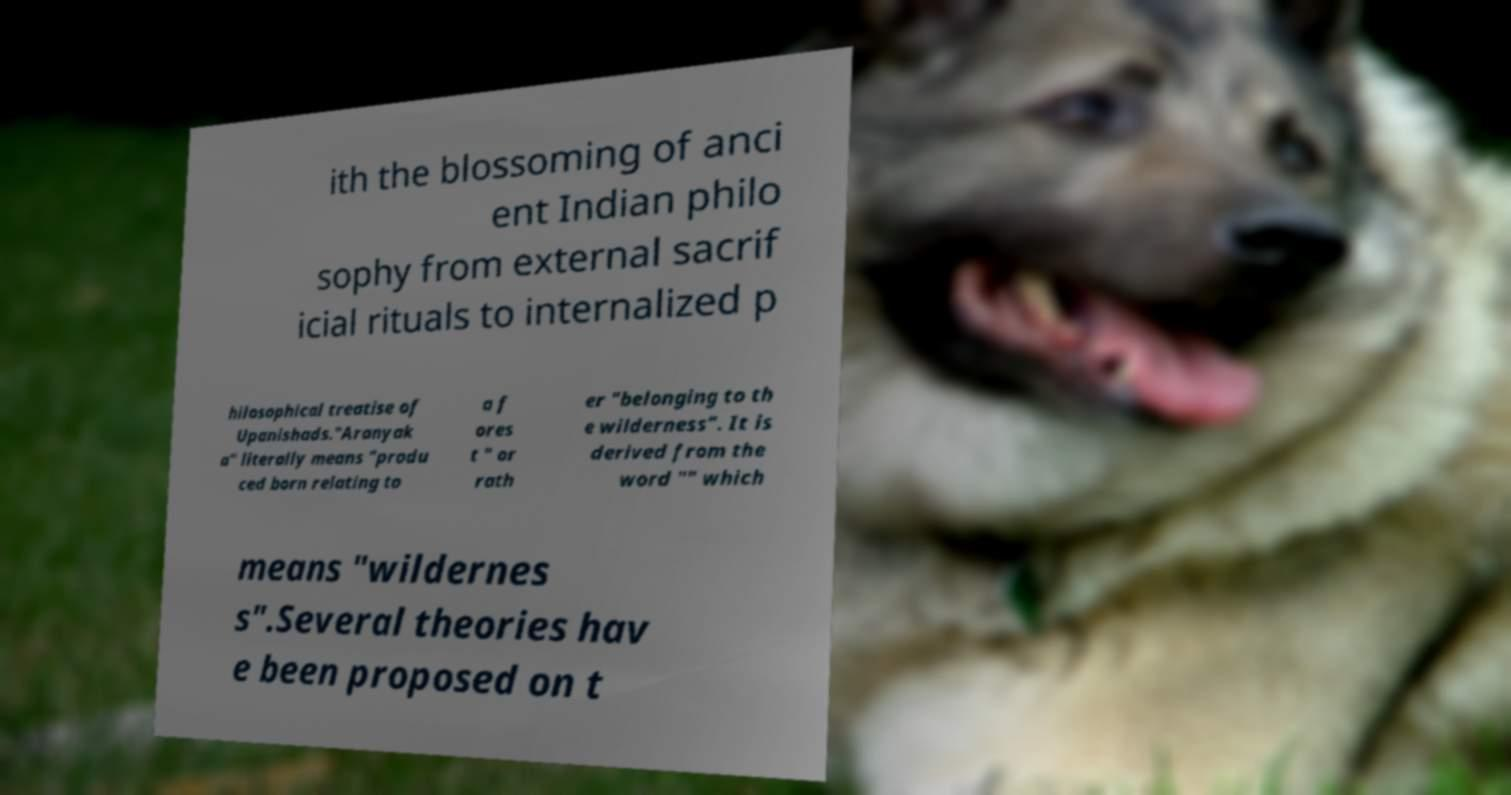Please read and relay the text visible in this image. What does it say? ith the blossoming of anci ent Indian philo sophy from external sacrif icial rituals to internalized p hilosophical treatise of Upanishads."Aranyak a" literally means "produ ced born relating to a f ores t " or rath er "belonging to th e wilderness". It is derived from the word "" which means "wildernes s".Several theories hav e been proposed on t 